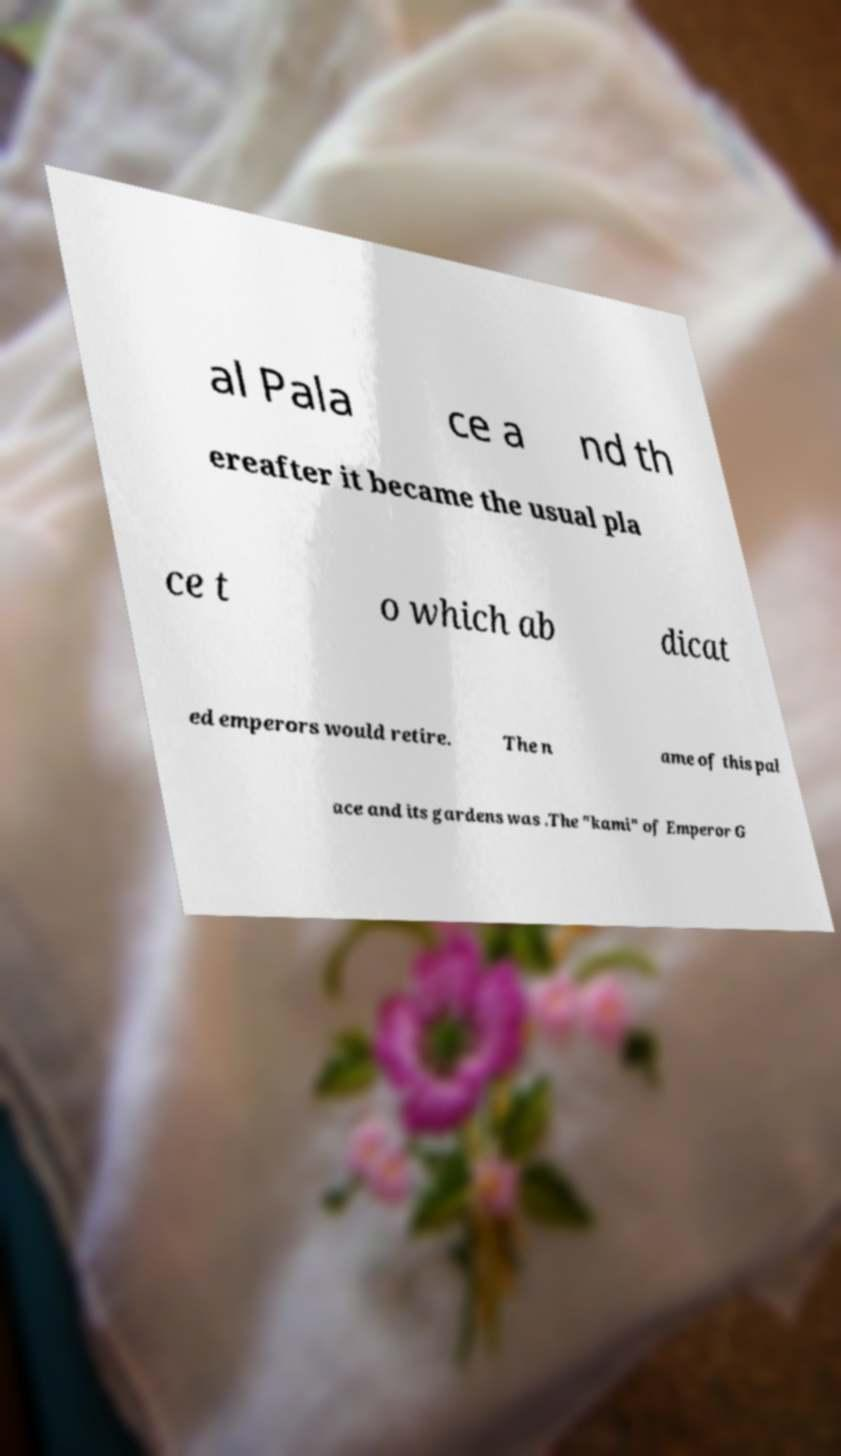For documentation purposes, I need the text within this image transcribed. Could you provide that? al Pala ce a nd th ereafter it became the usual pla ce t o which ab dicat ed emperors would retire. The n ame of this pal ace and its gardens was .The "kami" of Emperor G 